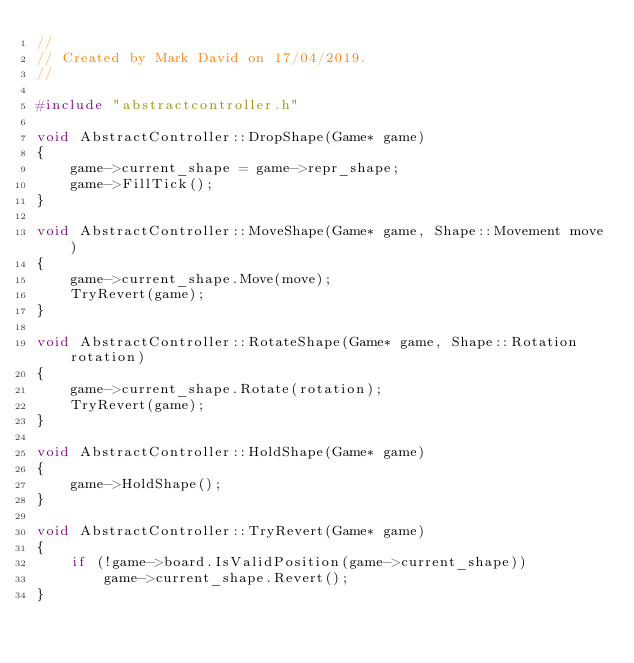<code> <loc_0><loc_0><loc_500><loc_500><_C++_>//
// Created by Mark David on 17/04/2019.
//

#include "abstractcontroller.h"

void AbstractController::DropShape(Game* game)
{
    game->current_shape = game->repr_shape;
    game->FillTick();
}

void AbstractController::MoveShape(Game* game, Shape::Movement move)
{
    game->current_shape.Move(move);
    TryRevert(game);
}

void AbstractController::RotateShape(Game* game, Shape::Rotation rotation)
{
    game->current_shape.Rotate(rotation);
    TryRevert(game);
}

void AbstractController::HoldShape(Game* game)
{
    game->HoldShape();
}

void AbstractController::TryRevert(Game* game)
{
    if (!game->board.IsValidPosition(game->current_shape))
        game->current_shape.Revert();
}
</code> 